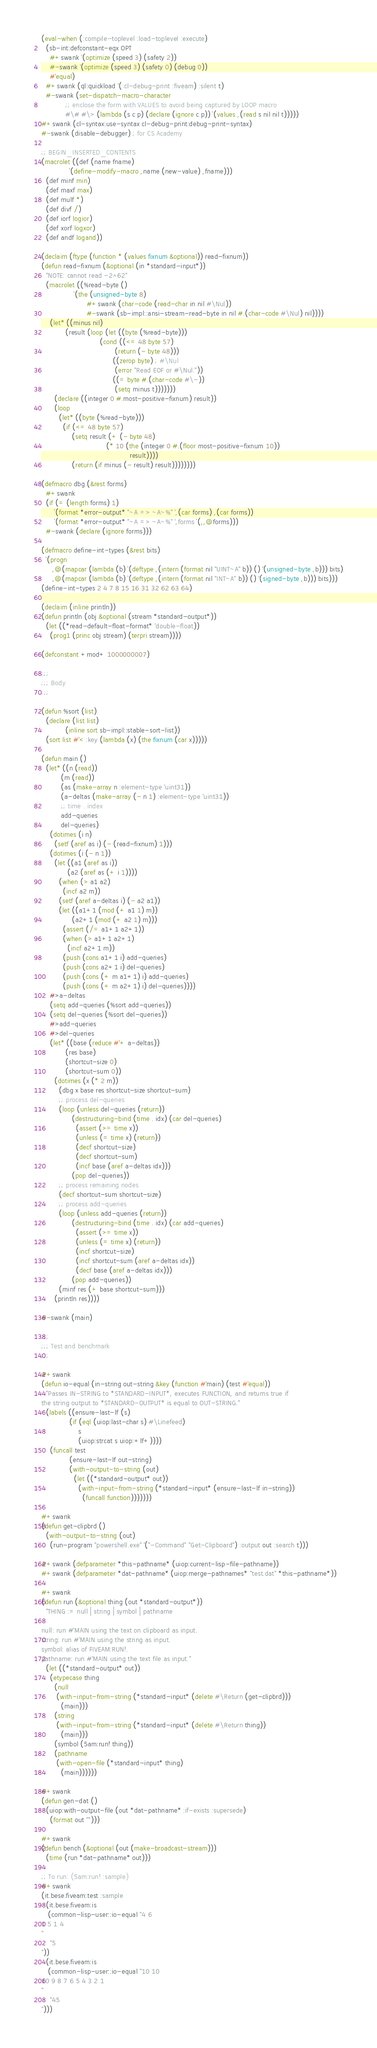Convert code to text. <code><loc_0><loc_0><loc_500><loc_500><_Lisp_>(eval-when (:compile-toplevel :load-toplevel :execute)
  (sb-int:defconstant-eqx OPT
    #+swank '(optimize (speed 3) (safety 2))
    #-swank '(optimize (speed 3) (safety 0) (debug 0))
    #'equal)
  #+swank (ql:quickload '(:cl-debug-print :fiveam) :silent t)
  #-swank (set-dispatch-macro-character
           ;; enclose the form with VALUES to avoid being captured by LOOP macro
           #\# #\> (lambda (s c p) (declare (ignore c p)) `(values ,(read s nil nil t)))))
#+swank (cl-syntax:use-syntax cl-debug-print:debug-print-syntax)
#-swank (disable-debugger) ; for CS Academy

;; BEGIN_INSERTED_CONTENTS
(macrolet ((def (name fname)
             `(define-modify-macro ,name (new-value) ,fname)))
  (def minf min)
  (def maxf max)
  (def mulf *)
  (def divf /)
  (def iorf logior)
  (def xorf logxor)
  (def andf logand))

(declaim (ftype (function * (values fixnum &optional)) read-fixnum))
(defun read-fixnum (&optional (in *standard-input*))
  "NOTE: cannot read -2^62"
  (macrolet ((%read-byte ()
               `(the (unsigned-byte 8)
                     #+swank (char-code (read-char in nil #\Nul))
                     #-swank (sb-impl::ansi-stream-read-byte in nil #.(char-code #\Nul) nil))))
    (let* ((minus nil)
           (result (loop (let ((byte (%read-byte)))
                           (cond ((<= 48 byte 57)
                                  (return (- byte 48)))
                                 ((zerop byte) ; #\Nul
                                  (error "Read EOF or #\Nul."))
                                 ((= byte #.(char-code #\-))
                                  (setq minus t)))))))
      (declare ((integer 0 #.most-positive-fixnum) result))
      (loop
        (let* ((byte (%read-byte)))
          (if (<= 48 byte 57)
              (setq result (+ (- byte 48)
                              (* 10 (the (integer 0 #.(floor most-positive-fixnum 10))
                                         result))))
              (return (if minus (- result) result))))))))

(defmacro dbg (&rest forms)
  #+swank
  (if (= (length forms) 1)
      `(format *error-output* "~A => ~A~%" ',(car forms) ,(car forms))
      `(format *error-output* "~A => ~A~%" ',forms `(,,@forms)))
  #-swank (declare (ignore forms)))

(defmacro define-int-types (&rest bits)
  `(progn
     ,@(mapcar (lambda (b) `(deftype ,(intern (format nil "UINT~A" b)) () '(unsigned-byte ,b))) bits)
     ,@(mapcar (lambda (b) `(deftype ,(intern (format nil "INT~A" b)) () '(signed-byte ,b))) bits)))
(define-int-types 2 4 7 8 15 16 31 32 62 63 64)

(declaim (inline println))
(defun println (obj &optional (stream *standard-output*))
  (let ((*read-default-float-format* 'double-float))
    (prog1 (princ obj stream) (terpri stream))))

(defconstant +mod+ 1000000007)

;;;
;;; Body
;;;

(defun %sort (list)
  (declare (list list)
           (inline sort sb-impl::stable-sort-list))
  (sort list #'< :key (lambda (x) (the fixnum (car x)))))

(defun main ()
  (let* ((n (read))
         (m (read))
         (as (make-array n :element-type 'uint31))
         (a-deltas (make-array (- n 1) :element-type 'uint31))
         ;; time . index
         add-queries
         del-queries)
    (dotimes (i n)
      (setf (aref as i) (- (read-fixnum) 1)))
    (dotimes (i (- n 1))
      (let ((a1 (aref as i))
            (a2 (aref as (+ i 1))))
        (when (> a1 a2)
          (incf a2 m))
        (setf (aref a-deltas i) (- a2 a1))
        (let ((a1+1 (mod (+ a1 1) m))
              (a2+1 (mod (+ a2 1) m)))
          (assert (/= a1+1 a2+1))
          (when (> a1+1 a2+1)
            (incf a2+1 m))
          (push (cons a1+1 i) add-queries)
          (push (cons a2+1 i) del-queries)
          (push (cons (+ m a1+1) i) add-queries)
          (push (cons (+ m a2+1) i) del-queries))))
    #>a-deltas
    (setq add-queries (%sort add-queries))
    (setq del-queries (%sort del-queries))
    #>add-queries
    #>del-queries
    (let* ((base (reduce #'+ a-deltas))
           (res base)
           (shortcut-size 0)
           (shortcut-sum 0))
      (dotimes (x (* 2 m))
        (dbg x base res shortcut-size shortcut-sum)
        ;; process del-queries
        (loop (unless del-queries (return))
              (destructuring-bind (time . idx) (car del-queries)
                (assert (>= time x))
                (unless (= time x) (return))
                (decf shortcut-size)
                (decf shortcut-sum)
                (incf base (aref a-deltas idx)))
              (pop del-queries))
        ;; process remaining nodes
        (decf shortcut-sum shortcut-size)
        ;; process add-queries
        (loop (unless add-queries (return))
              (destructuring-bind (time . idx) (car add-queries)
                (assert (>= time x))
                (unless (= time x) (return))
                (incf shortcut-size)
                (incf shortcut-sum (aref a-deltas idx))
                (decf base (aref a-deltas idx)))
              (pop add-queries))
        (minf res (+ base shortcut-sum)))
      (println res))))

#-swank (main)

;;;
;;; Test and benchmark
;;;

#+swank
(defun io-equal (in-string out-string &key (function #'main) (test #'equal))
  "Passes IN-STRING to *STANDARD-INPUT*, executes FUNCTION, and returns true if
the string output to *STANDARD-OUTPUT* is equal to OUT-STRING."
  (labels ((ensure-last-lf (s)
             (if (eql (uiop:last-char s) #\Linefeed)
                 s
                 (uiop:strcat s uiop:+lf+))))
    (funcall test
             (ensure-last-lf out-string)
             (with-output-to-string (out)
               (let ((*standard-output* out))
                 (with-input-from-string (*standard-input* (ensure-last-lf in-string))
                   (funcall function)))))))

#+swank
(defun get-clipbrd ()
  (with-output-to-string (out)
    (run-program "powershell.exe" '("-Command" "Get-Clipboard") :output out :search t)))

#+swank (defparameter *this-pathname* (uiop:current-lisp-file-pathname))
#+swank (defparameter *dat-pathname* (uiop:merge-pathnames* "test.dat" *this-pathname*))

#+swank
(defun run (&optional thing (out *standard-output*))
  "THING := null | string | symbol | pathname

null: run #'MAIN using the text on clipboard as input.
string: run #'MAIN using the string as input.
symbol: alias of FIVEAM:RUN!.
pathname: run #'MAIN using the text file as input."
  (let ((*standard-output* out))
    (etypecase thing
      (null
       (with-input-from-string (*standard-input* (delete #\Return (get-clipbrd)))
         (main)))
      (string
       (with-input-from-string (*standard-input* (delete #\Return thing))
         (main)))
      (symbol (5am:run! thing))
      (pathname
       (with-open-file (*standard-input* thing)
         (main))))))

#+swank
(defun gen-dat ()
  (uiop:with-output-file (out *dat-pathname* :if-exists :supersede)
    (format out "")))

#+swank
(defun bench (&optional (out (make-broadcast-stream)))
  (time (run *dat-pathname* out)))

;; To run: (5am:run! :sample)
#+swank
(it.bese.fiveam:test :sample
  (it.bese.fiveam:is
   (common-lisp-user::io-equal "4 6
1 5 1 4
"
    "5
"))
  (it.bese.fiveam:is
   (common-lisp-user::io-equal "10 10
10 9 8 7 6 5 4 3 2 1
"
    "45
")))
</code> 